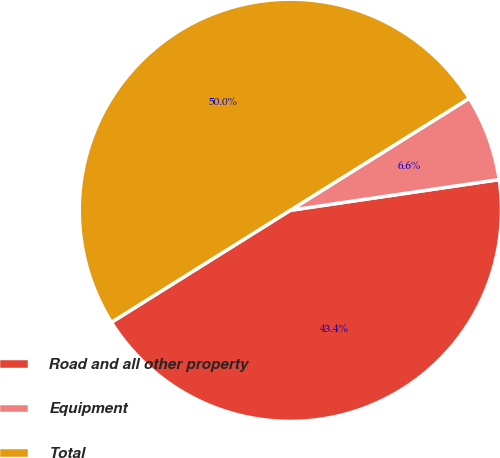<chart> <loc_0><loc_0><loc_500><loc_500><pie_chart><fcel>Road and all other property<fcel>Equipment<fcel>Total<nl><fcel>43.42%<fcel>6.58%<fcel>50.0%<nl></chart> 